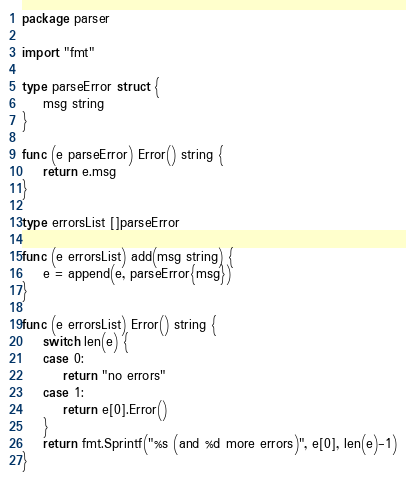Convert code to text. <code><loc_0><loc_0><loc_500><loc_500><_Go_>package parser

import "fmt"

type parseError struct {
	msg string
}

func (e parseError) Error() string {
	return e.msg
}

type errorsList []parseError

func (e errorsList) add(msg string) {
	e = append(e, parseError{msg})
}

func (e errorsList) Error() string {
	switch len(e) {
	case 0:
		return "no errors"
	case 1:
		return e[0].Error()
	}
	return fmt.Sprintf("%s (and %d more errors)", e[0], len(e)-1)
}
</code> 